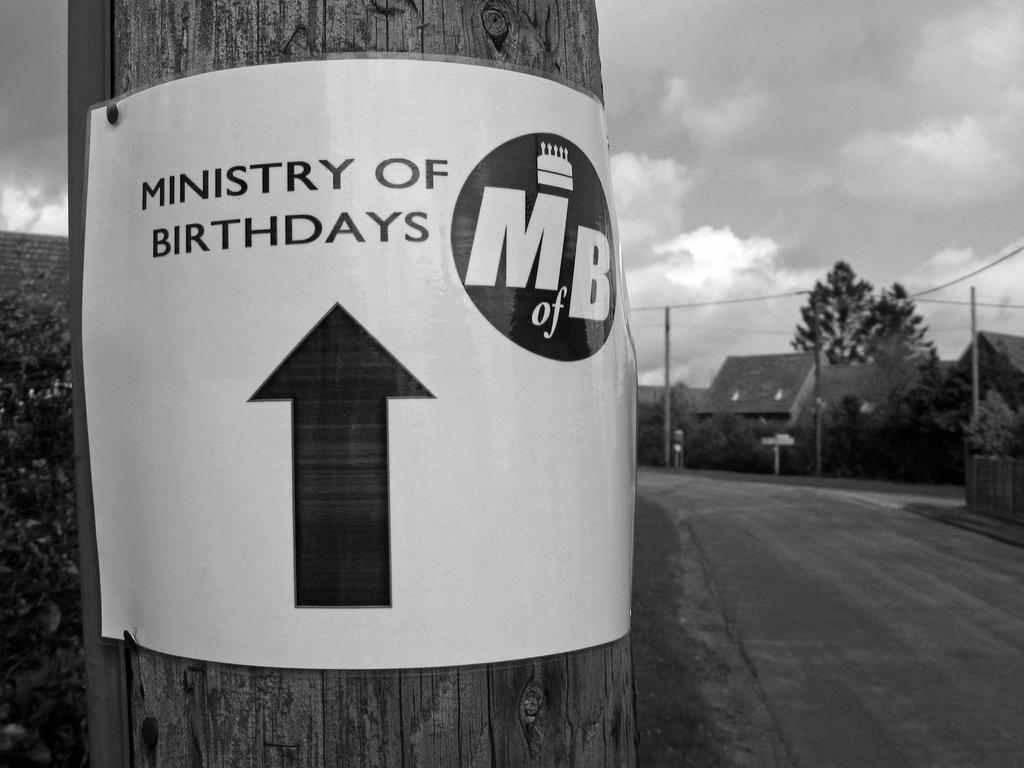<image>
Write a terse but informative summary of the picture. White sign on a pole which says Ministry of Birthdays. 